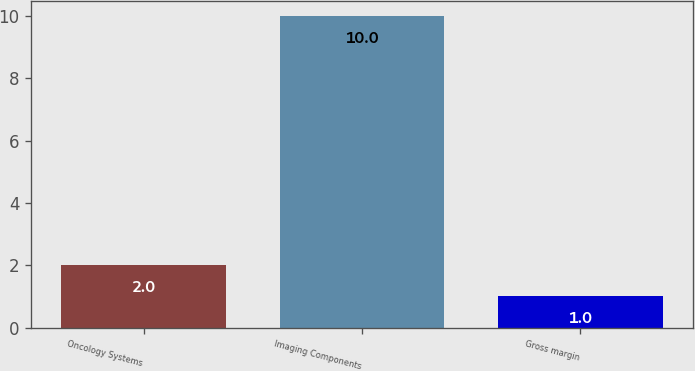Convert chart to OTSL. <chart><loc_0><loc_0><loc_500><loc_500><bar_chart><fcel>Oncology Systems<fcel>Imaging Components<fcel>Gross margin<nl><fcel>2<fcel>10<fcel>1<nl></chart> 